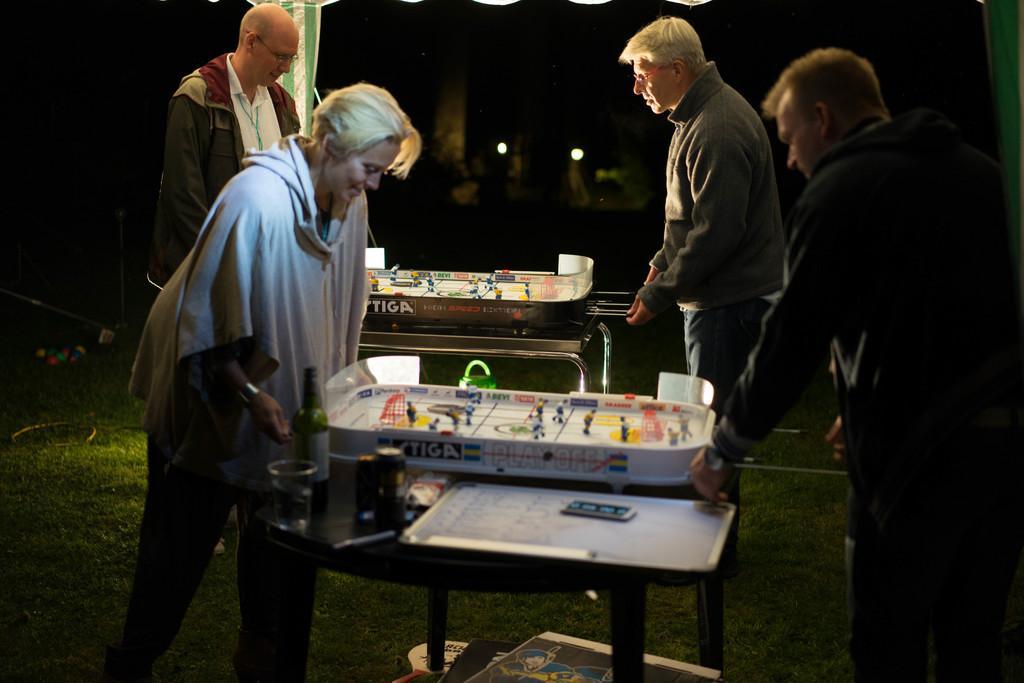Please provide a concise description of this image. there are 4 people standing. on the table there is a whiteboard , bottle , glass and a game. 